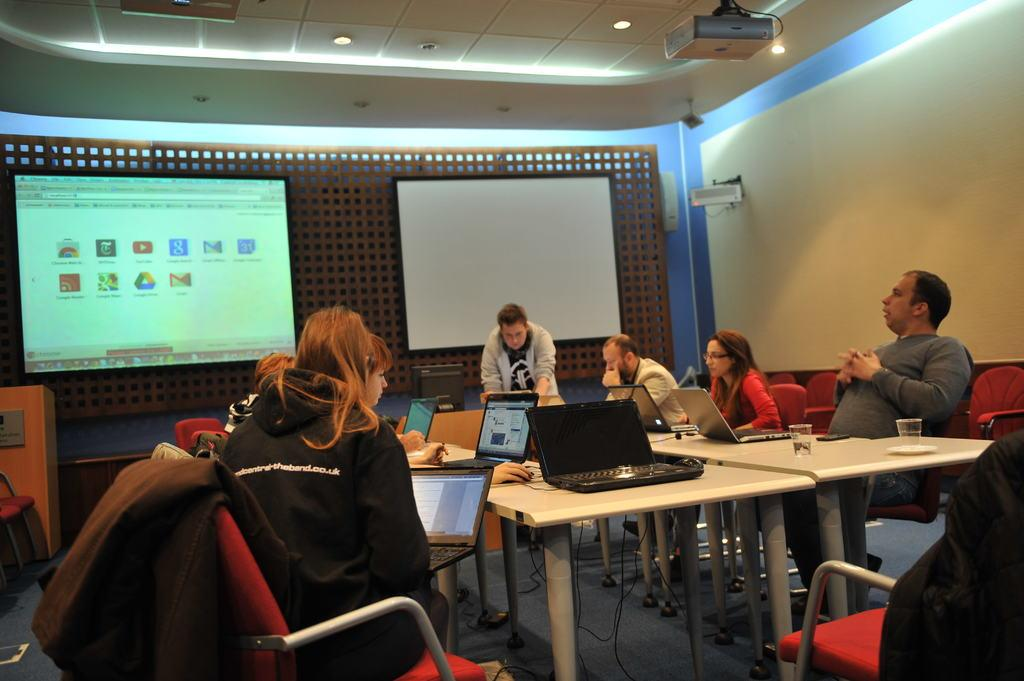What are the people in the image doing? The people in the image are sitting on chairs. What objects are present in the image besides the people? There are tables in the image. What can be seen on the tables in the image? There are laptops on the tables in the image. What type of corn is growing on the wall in the image? There is no corn or wall present in the image; it features people sitting on chairs with tables and laptops. 